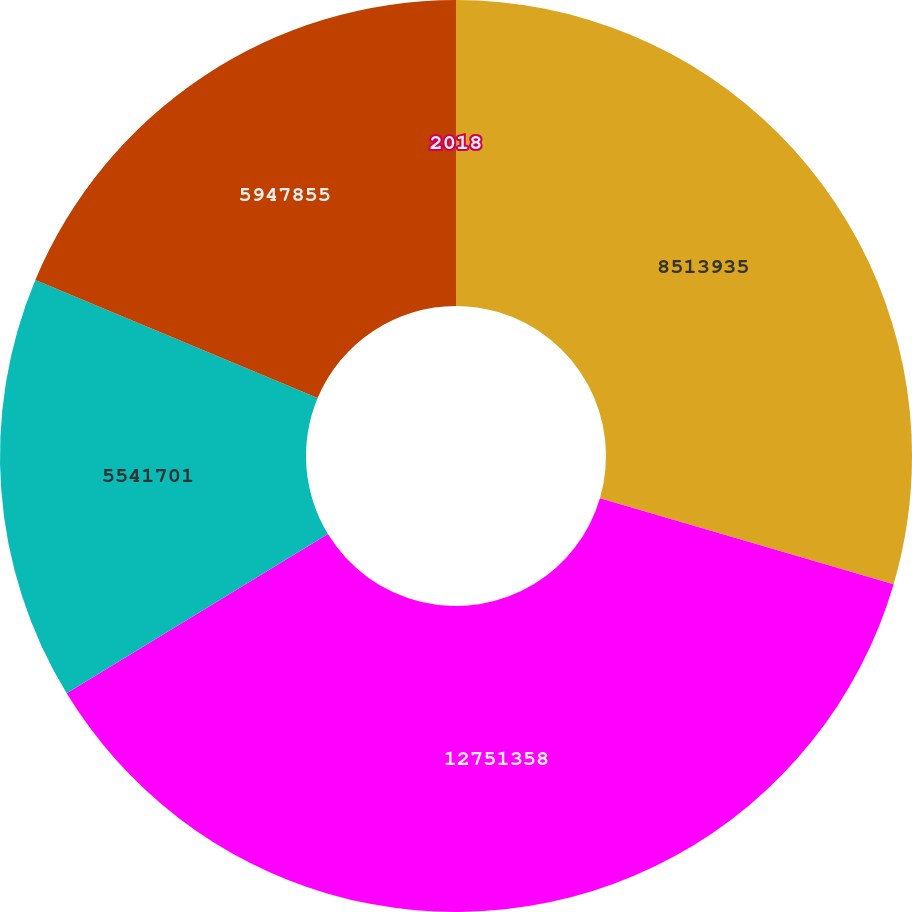Convert chart to OTSL. <chart><loc_0><loc_0><loc_500><loc_500><pie_chart><fcel>2018<fcel>8513935<fcel>12751358<fcel>5541701<fcel>5947855<nl><fcel>0.0%<fcel>29.53%<fcel>36.75%<fcel>15.02%<fcel>18.69%<nl></chart> 